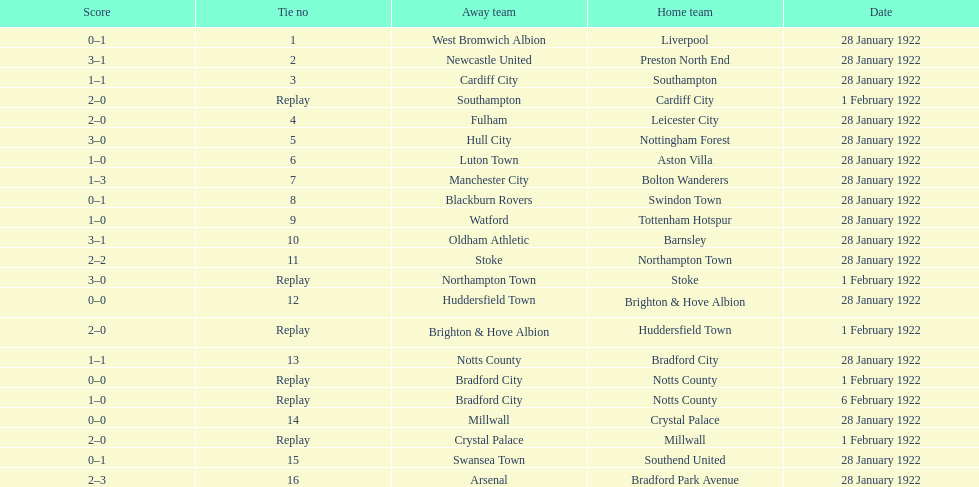How many total points were scored in the second round proper? 45. 